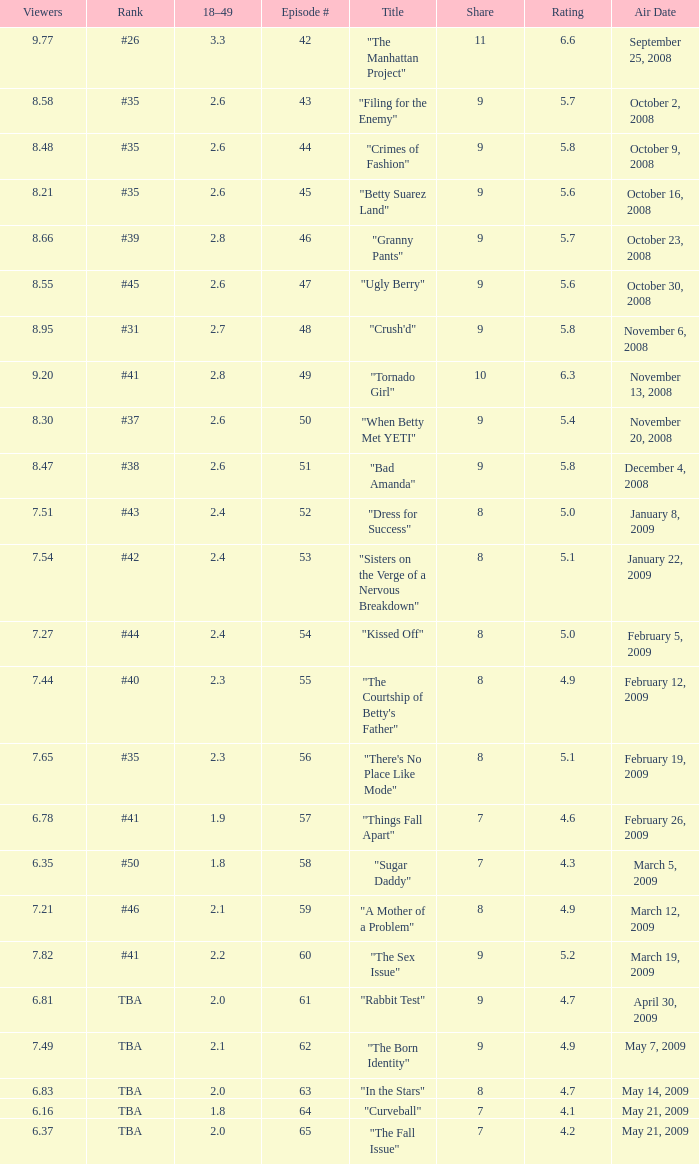What is the average Episode # with a 7 share and 18–49 is less than 2 and the Air Date of may 21, 2009? 64.0. 